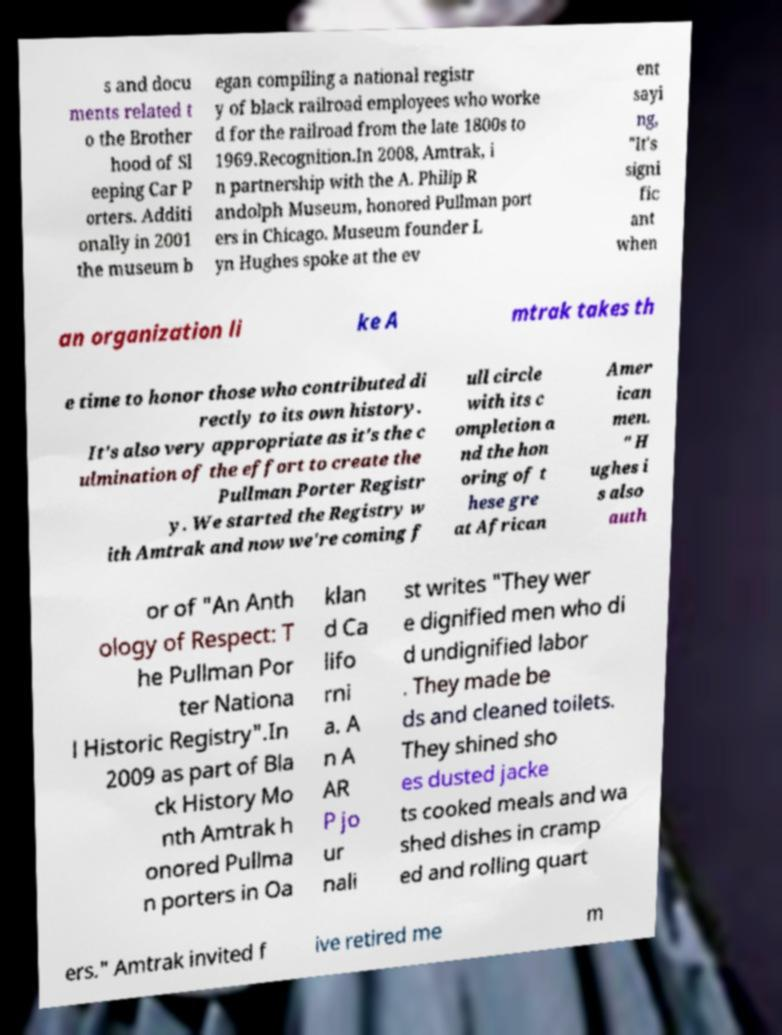What messages or text are displayed in this image? I need them in a readable, typed format. s and docu ments related t o the Brother hood of Sl eeping Car P orters. Additi onally in 2001 the museum b egan compiling a national registr y of black railroad employees who worke d for the railroad from the late 1800s to 1969.Recognition.In 2008, Amtrak, i n partnership with the A. Philip R andolph Museum, honored Pullman port ers in Chicago. Museum founder L yn Hughes spoke at the ev ent sayi ng, "It's signi fic ant when an organization li ke A mtrak takes th e time to honor those who contributed di rectly to its own history. It's also very appropriate as it's the c ulmination of the effort to create the Pullman Porter Registr y. We started the Registry w ith Amtrak and now we're coming f ull circle with its c ompletion a nd the hon oring of t hese gre at African Amer ican men. " H ughes i s also auth or of "An Anth ology of Respect: T he Pullman Por ter Nationa l Historic Registry".In 2009 as part of Bla ck History Mo nth Amtrak h onored Pullma n porters in Oa klan d Ca lifo rni a. A n A AR P jo ur nali st writes "They wer e dignified men who di d undignified labor . They made be ds and cleaned toilets. They shined sho es dusted jacke ts cooked meals and wa shed dishes in cramp ed and rolling quart ers." Amtrak invited f ive retired me m 